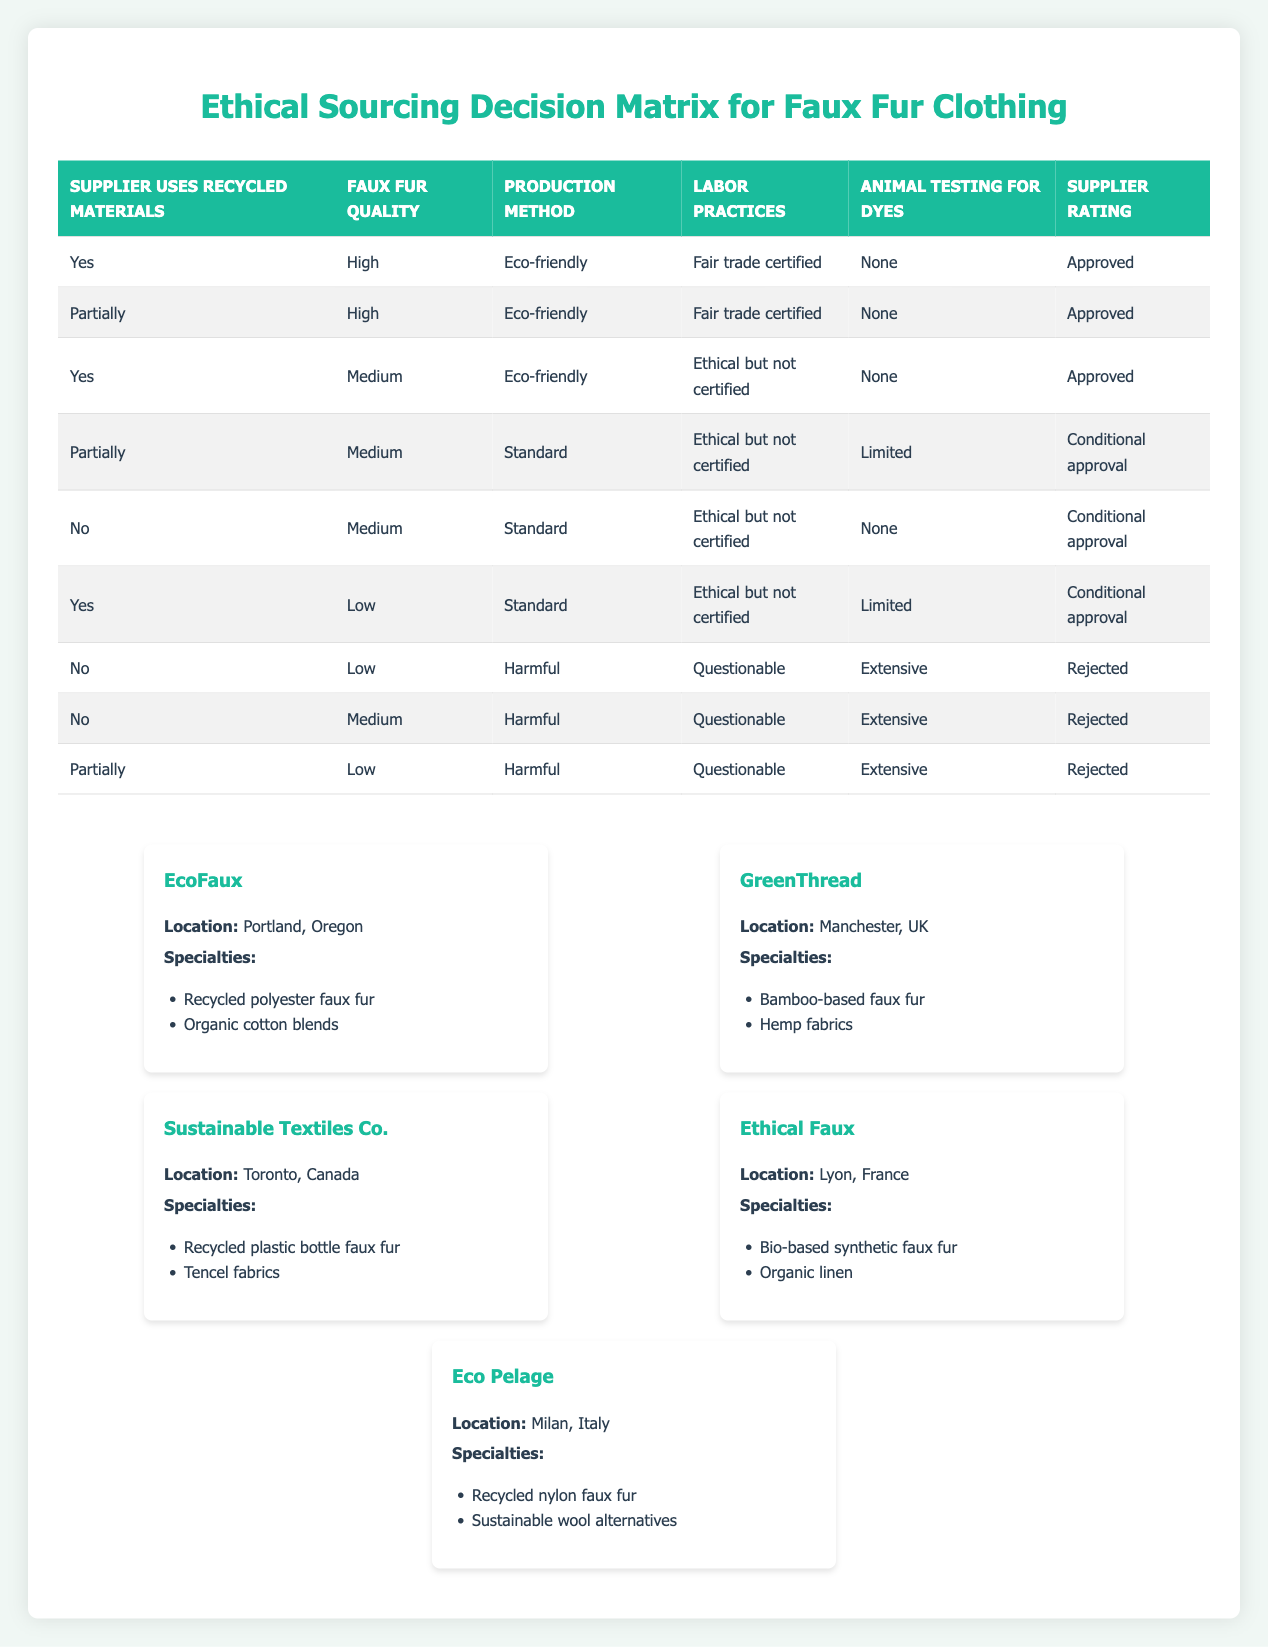What is the supplier rating if the supplier uses recycled materials and has high faux fur quality? According to the table, if a supplier uses recycled materials and the faux fur quality is high, the corresponding supplier rating is "Approved."
Answer: Approved How many suppliers have a production method classified as "Harmful"? There are three rows in the table where the production method is "Harmful." By counting these, we find that the total is three suppliers.
Answer: 3 Is it true that a supplier with medium faux fur quality and ethical but not certified labor practices cannot be approved? Yes, it is true because the rules indicate that suppliers with medium faux fur quality and ethical but not certified labor practices are marked either as "Conditional approval" or "Rejected," not "Approved."
Answer: Yes What are the criteria for a supplier to be "Rejected"? A supplier is marked as "Rejected" if they use materials classified as "No" or have harmful production methods, questionable labor practices, and extensive animal testing for dyes, as shown by the rules.
Answer: No, low What is the supplier rating for a supplier that uses recycled materials, has medium quality, and harmful production practices? The conditions show that if a supplier uses recycled materials and has medium quality but harmful production practices, it typically leads to a "Conditional approval."
Answer: Conditional approval How many suppliers rated "Approved" use sustainable practices? From the table, two suppliers are rated "Approved" using sustainable practices that align with the criteria of high faux fur quality and eco-friendly production methods.
Answer: 2 Are there any suppliers rated "Conditional approval" that use partially recycled materials? Yes, according to the table, there are suppliers rated "Conditional approval" that use partially recycled materials and have various combinations of quality, production methods, and labor practices.
Answer: Yes What is the specific rating for a supplier with low quality, harmful production practices, and questionable labor practices? The supplier exhibiting low faux fur quality, harmful production practices, and questionable labor practices is rated "Rejected" as outlined in the table.
Answer: Rejected How do the conditions differ between suppliers with "Approved" and "Conditional approval"? The primary difference lies in the combination of materials usage, quality levels, production methods, and labor practices. Approved suppliers must meet higher criteria, such as having high quality and eco-friendly production methods, whereas conditional approvals may compromise on these criteria.
Answer: High criteria 